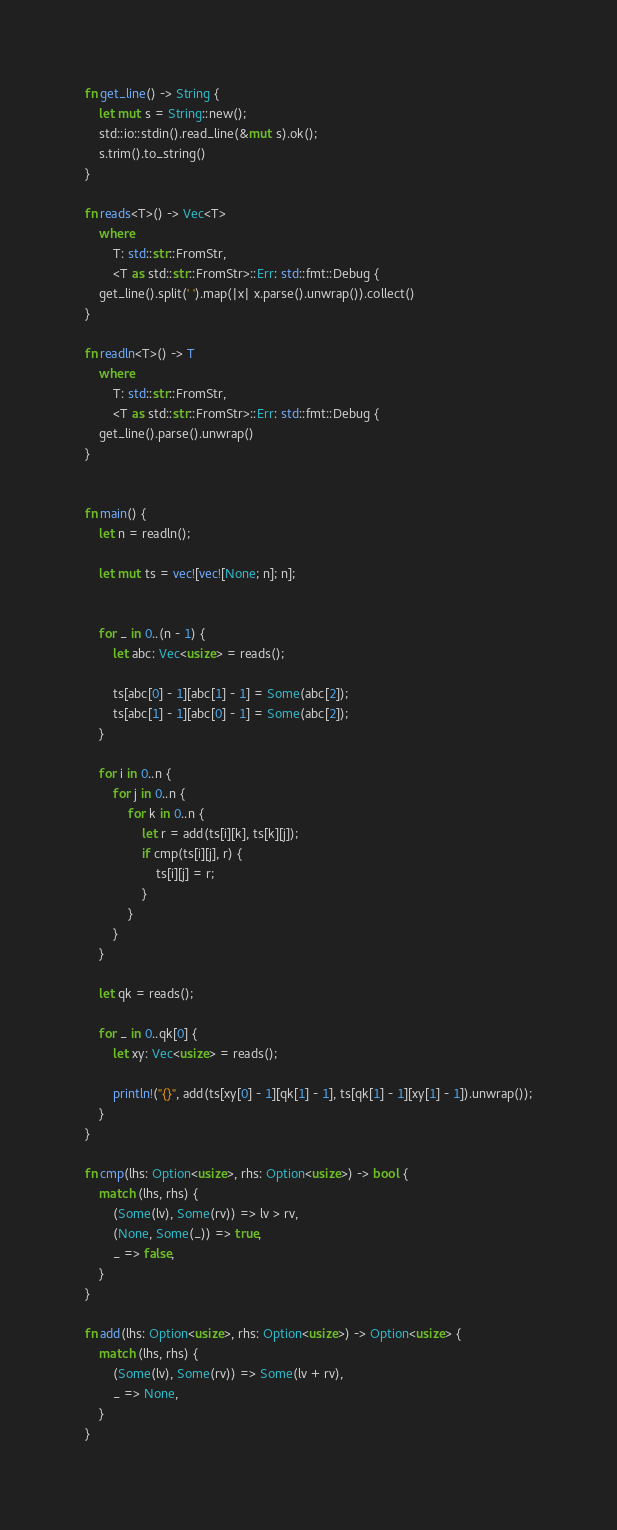Convert code to text. <code><loc_0><loc_0><loc_500><loc_500><_Rust_>fn get_line() -> String {
    let mut s = String::new();
    std::io::stdin().read_line(&mut s).ok();
    s.trim().to_string()
}

fn reads<T>() -> Vec<T>
    where
        T: std::str::FromStr,
        <T as std::str::FromStr>::Err: std::fmt::Debug {
    get_line().split(' ').map(|x| x.parse().unwrap()).collect()
}

fn readln<T>() -> T
    where
        T: std::str::FromStr,
        <T as std::str::FromStr>::Err: std::fmt::Debug {
    get_line().parse().unwrap()
}


fn main() {
    let n = readln();

    let mut ts = vec![vec![None; n]; n];


    for _ in 0..(n - 1) {
        let abc: Vec<usize> = reads();

        ts[abc[0] - 1][abc[1] - 1] = Some(abc[2]);
        ts[abc[1] - 1][abc[0] - 1] = Some(abc[2]);
    }

    for i in 0..n {
        for j in 0..n {
            for k in 0..n {
                let r = add(ts[i][k], ts[k][j]);
                if cmp(ts[i][j], r) {
                    ts[i][j] = r;
                }
            }
        }
    }

    let qk = reads();

    for _ in 0..qk[0] {
        let xy: Vec<usize> = reads();

        println!("{}", add(ts[xy[0] - 1][qk[1] - 1], ts[qk[1] - 1][xy[1] - 1]).unwrap());
    }
}

fn cmp(lhs: Option<usize>, rhs: Option<usize>) -> bool {
    match (lhs, rhs) {
        (Some(lv), Some(rv)) => lv > rv,
        (None, Some(_)) => true,
        _ => false,
    }
}

fn add(lhs: Option<usize>, rhs: Option<usize>) -> Option<usize> {
    match (lhs, rhs) {
        (Some(lv), Some(rv)) => Some(lv + rv),
        _ => None,
    }
}
</code> 